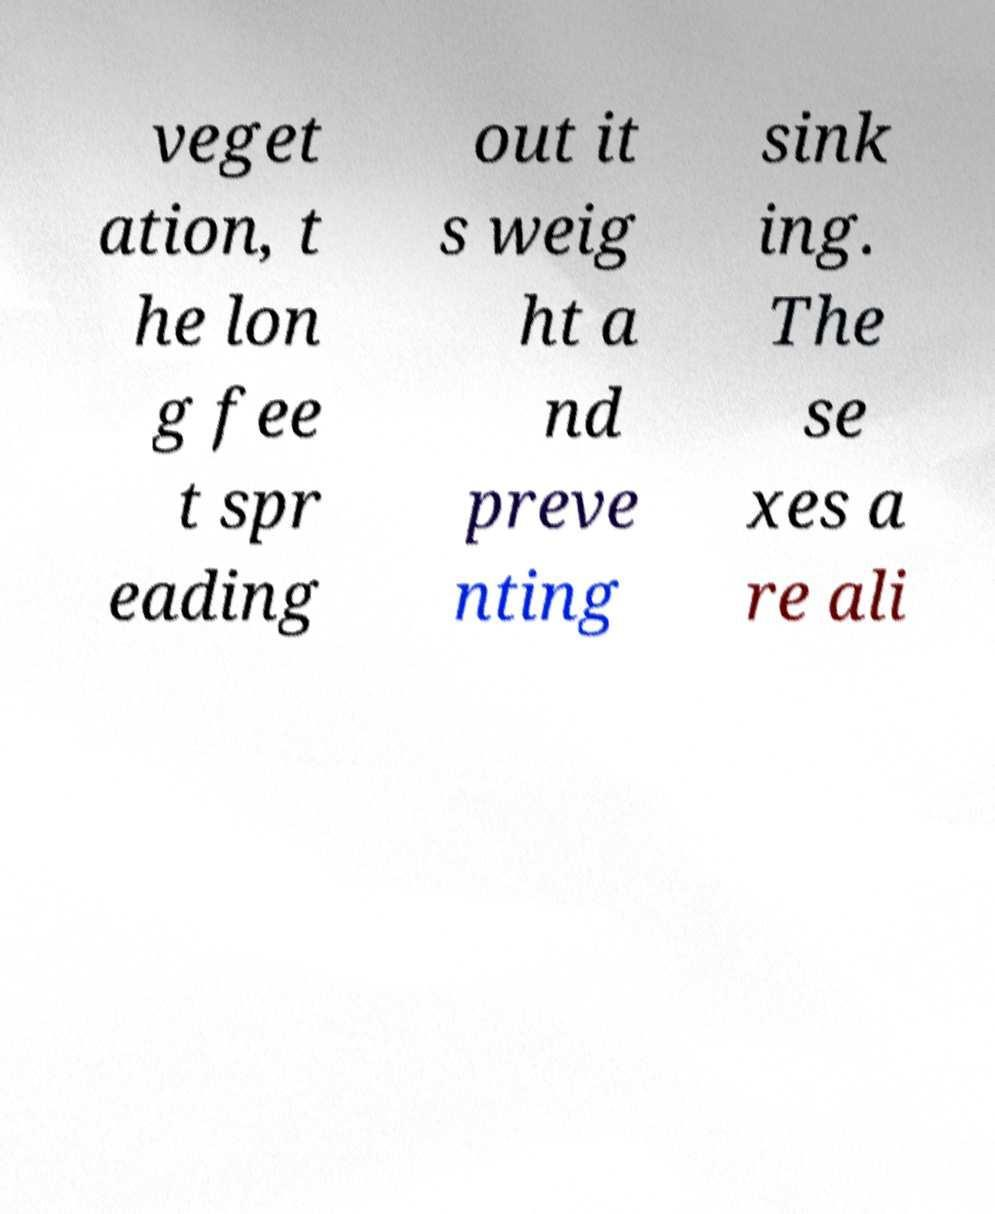Please identify and transcribe the text found in this image. veget ation, t he lon g fee t spr eading out it s weig ht a nd preve nting sink ing. The se xes a re ali 